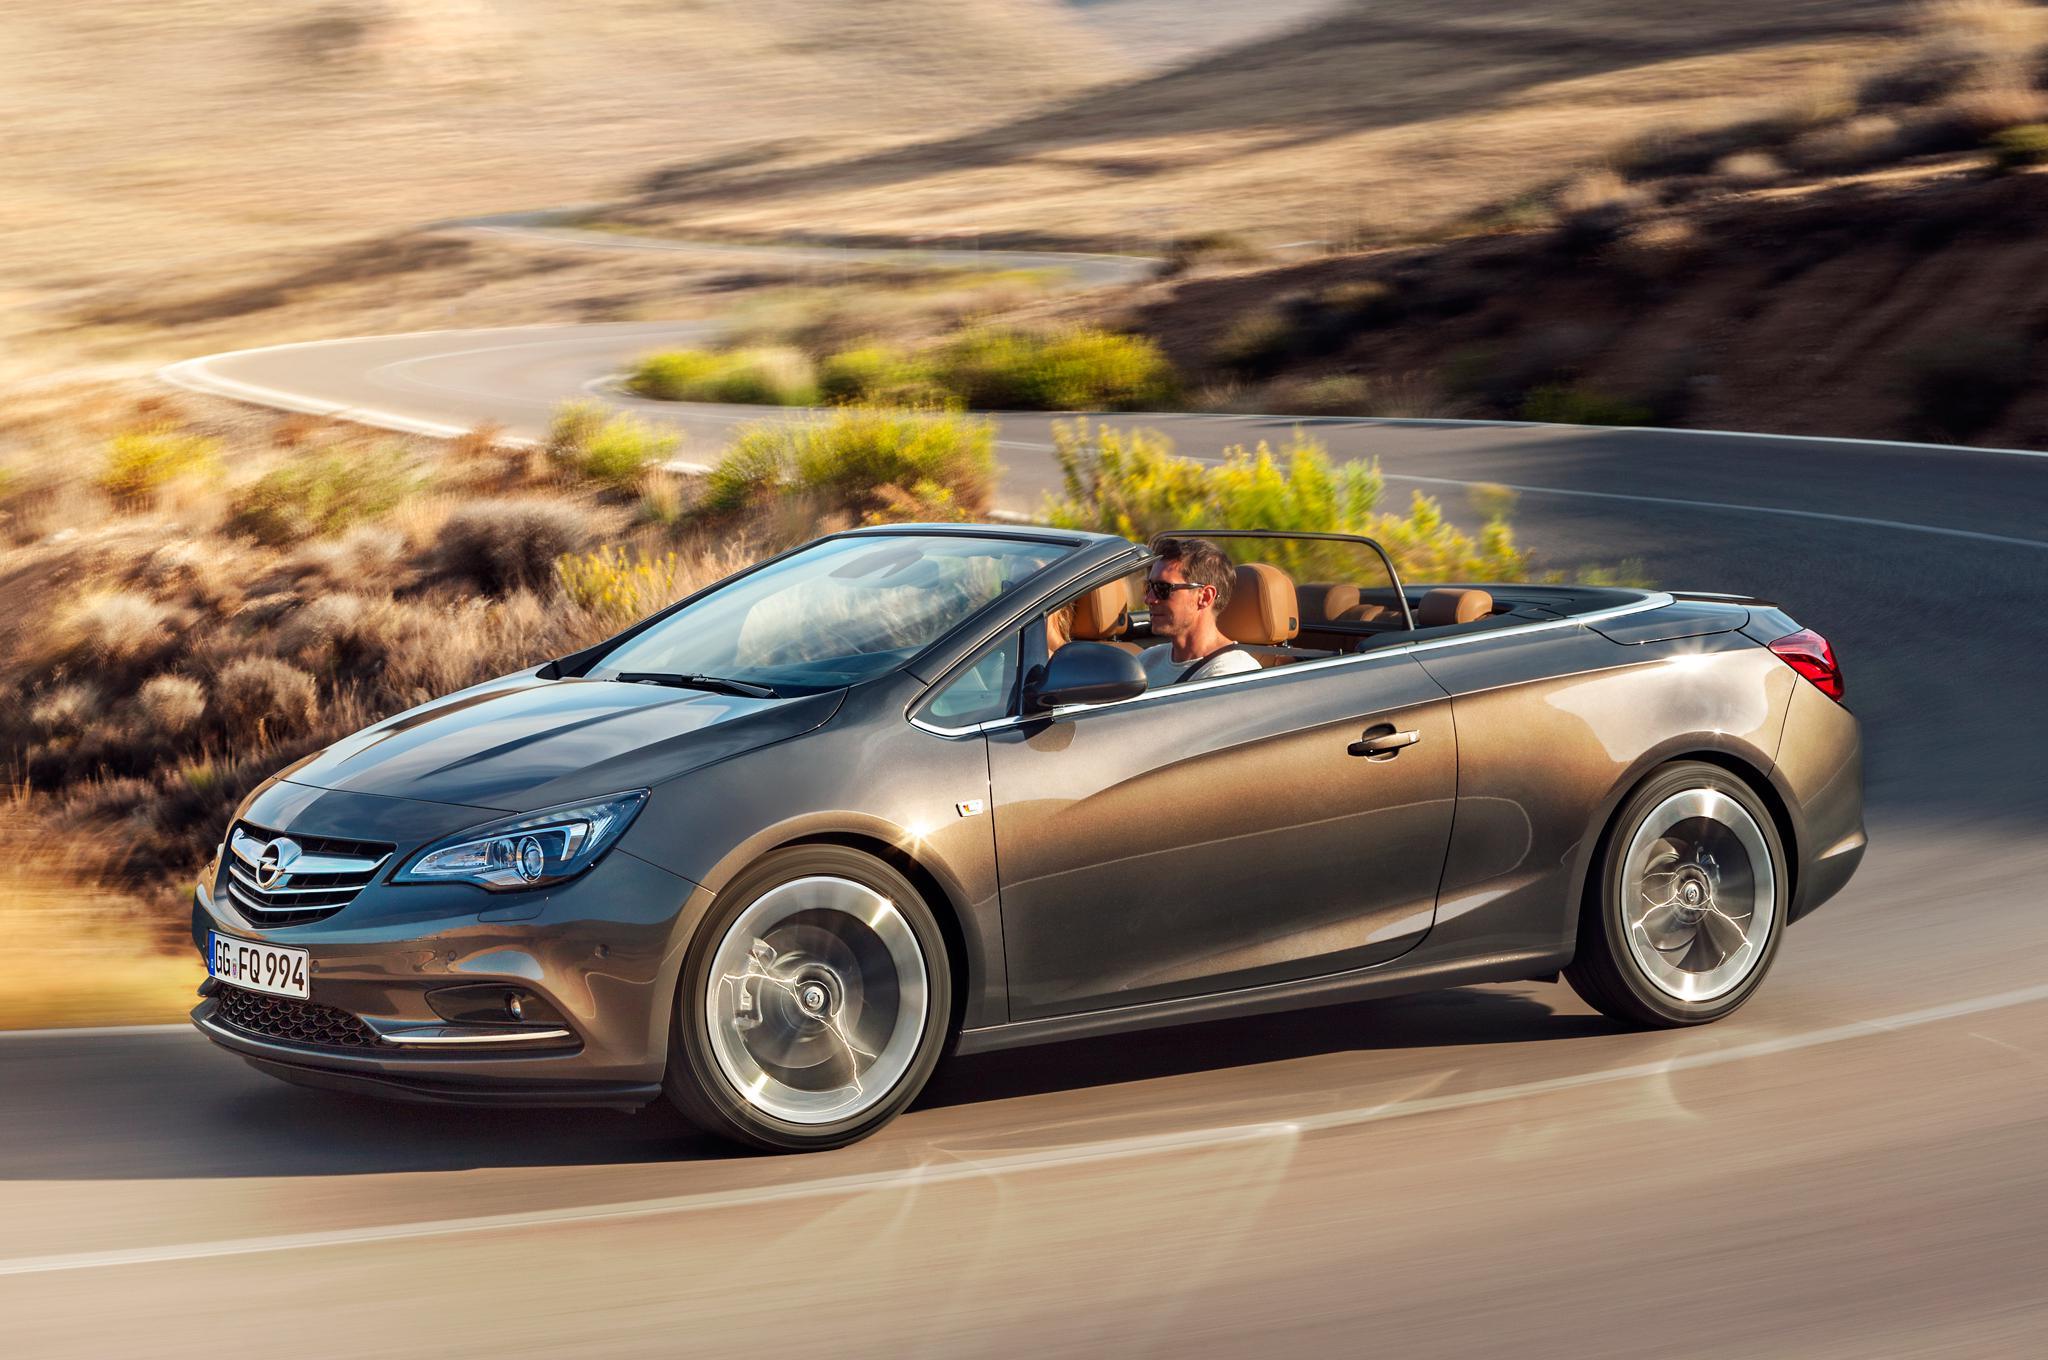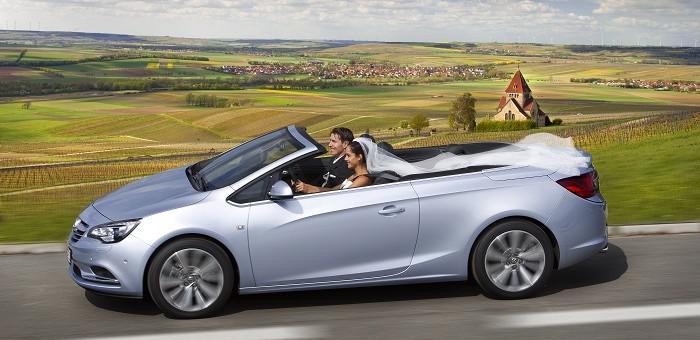The first image is the image on the left, the second image is the image on the right. Given the left and right images, does the statement "Each image contains a single blue convertible with its top down, and at least one has a driver." hold true? Answer yes or no. No. The first image is the image on the left, the second image is the image on the right. Analyze the images presented: Is the assertion "There is more than one person in the car in the image on the right." valid? Answer yes or no. Yes. 